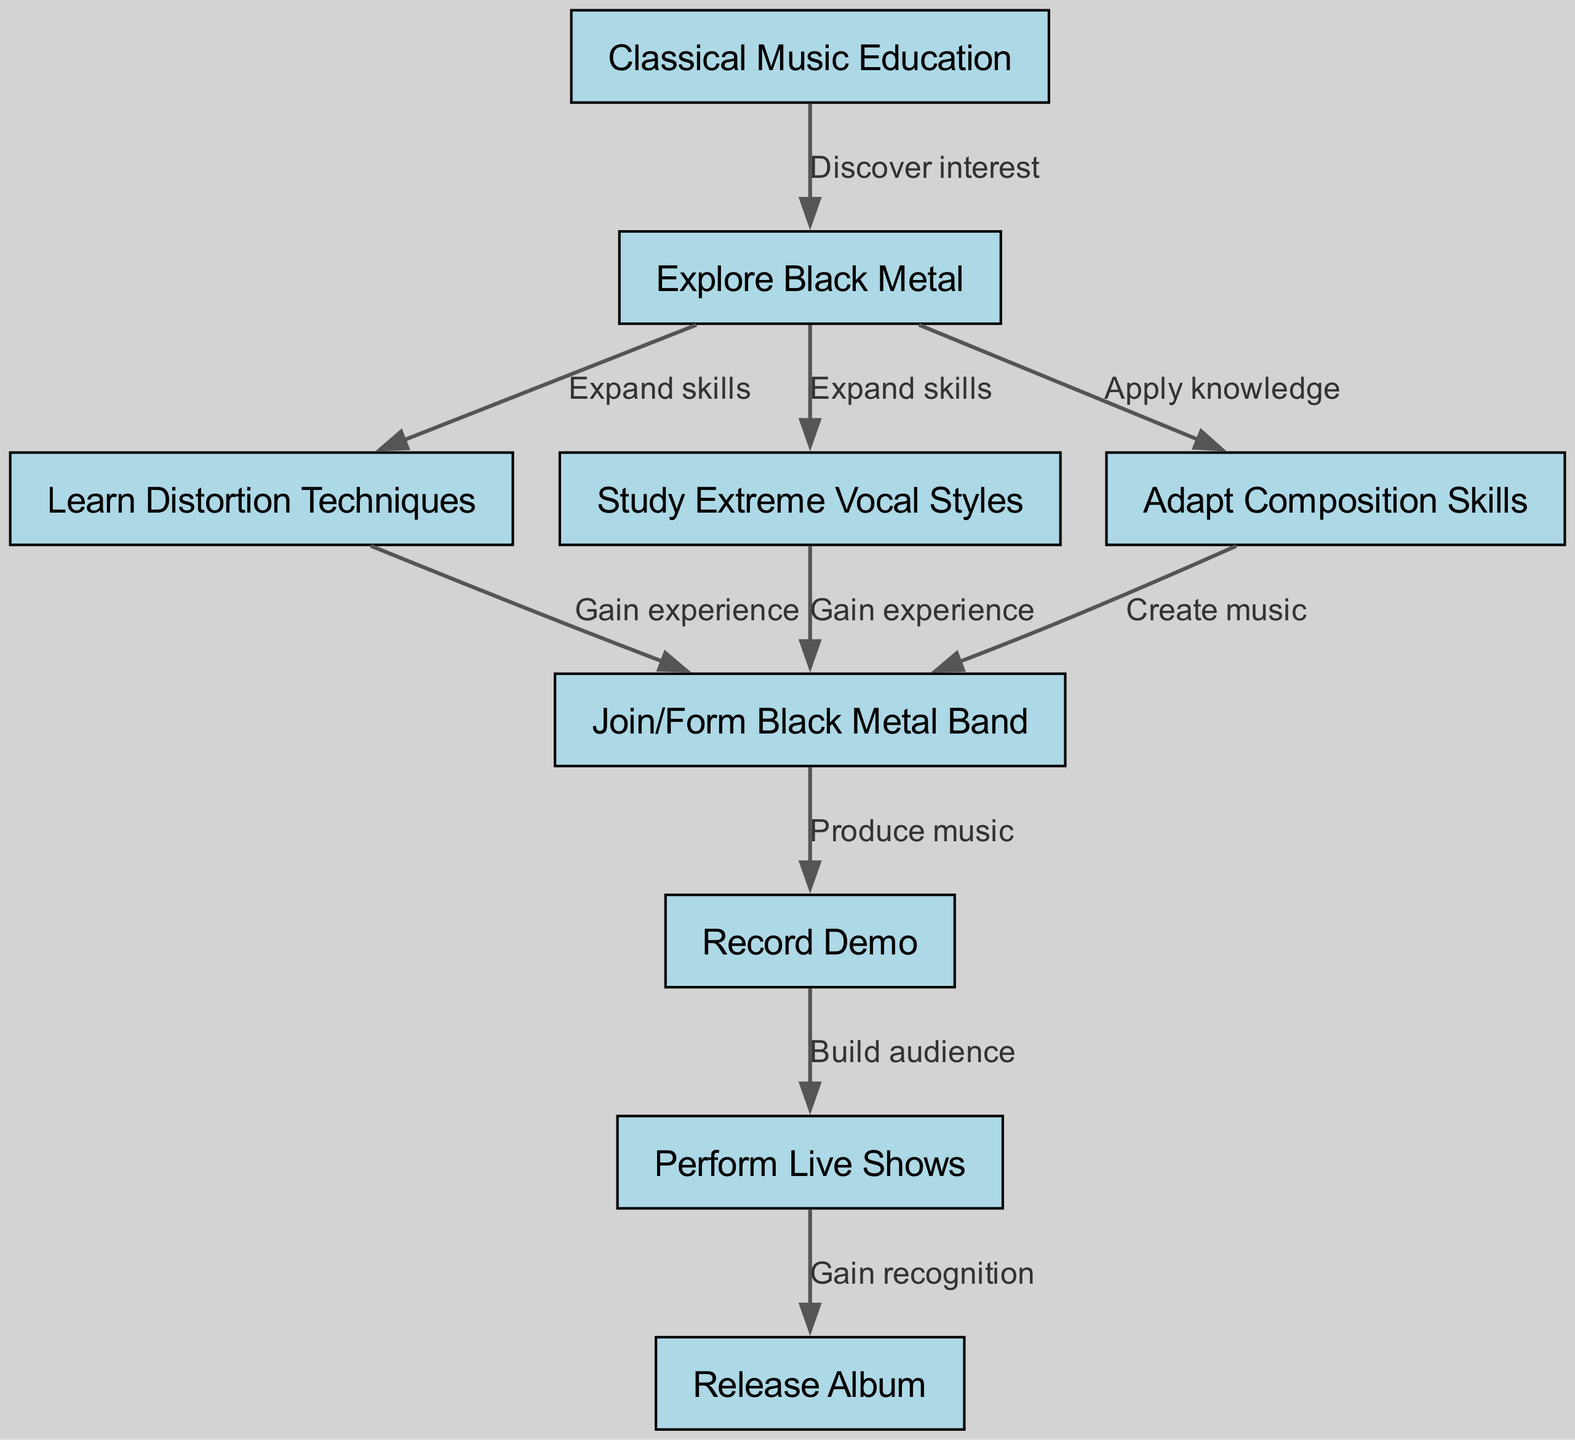What is the starting point of the career path? The diagram begins with the node labeled "Classical Music Education," indicating this is where the career path starts.
Answer: Classical Music Education How many nodes are there in the diagram? By counting the listed nodes in the diagram, there are a total of nine distinct nodes.
Answer: 9 What are the skills expanded after exploring black metal? The diagram shows that after "Explore Black Metal," one can expand their skills by learning distortion techniques, studying extreme vocal styles, and adapting composition skills.
Answer: Distortion techniques, extreme vocal styles, adaptation of composition skills What is the relationship between "Learn Distortion Techniques" and "Join/Form Black Metal Band"? There is a directed edge from "Learn Distortion Techniques" to "Join/Form Black Metal Band," which signifies that after learning distortion techniques, the musician gains experience that leads them to join or form a band.
Answer: Gain experience What sequence follows "Record Demo" in the career path? According to the diagram, the next step after "Record Demo" is "Perform Live Shows," indicating a progression in the musician's career.
Answer: Perform Live Shows Which nodes represent a transition into performance? The diagram illustrates that the transitions into performance occur at the nodes "Join/Form Black Metal Band," "Record Demo," and "Perform Live Shows."
Answer: Join/Form Black Metal Band, Record Demo, Perform Live Shows What is the final outcome in this career path? The final node in this career path progression is labeled "Release Album," indicating the completion of the musician's journey.
Answer: Release Album What is the total number of edges in the diagram? By assessing the connections or edges that represent the relationships between the nodes, there are ten edges in total.
Answer: 10 What does the musician need to do after "Join/Form Black Metal Band"? The following action the musician takes after joining or forming a band, as shown in the diagram, is to "Record Demo".
Answer: Record Demo 